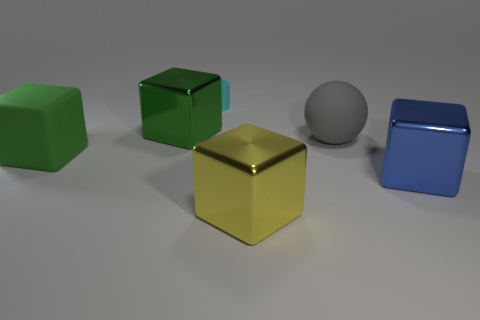Add 1 tiny blue metal spheres. How many objects exist? 7 Subtract all balls. How many objects are left? 5 Add 4 cyan cylinders. How many cyan cylinders are left? 5 Add 1 red things. How many red things exist? 1 Subtract 1 blue blocks. How many objects are left? 5 Subtract all big gray rubber balls. Subtract all gray matte balls. How many objects are left? 4 